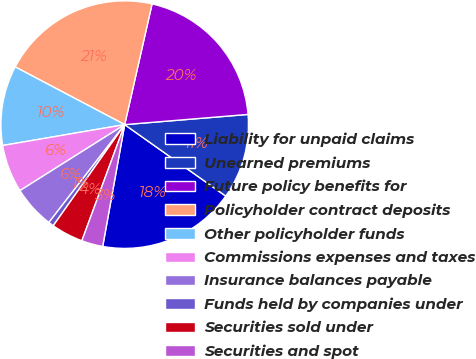Convert chart to OTSL. <chart><loc_0><loc_0><loc_500><loc_500><pie_chart><fcel>Liability for unpaid claims<fcel>Unearned premiums<fcel>Future policy benefits for<fcel>Policyholder contract deposits<fcel>Other policyholder funds<fcel>Commissions expenses and taxes<fcel>Insurance balances payable<fcel>Funds held by companies under<fcel>Securities sold under<fcel>Securities and spot<nl><fcel>18.05%<fcel>11.11%<fcel>20.14%<fcel>20.83%<fcel>10.42%<fcel>6.25%<fcel>5.56%<fcel>0.7%<fcel>4.17%<fcel>2.78%<nl></chart> 